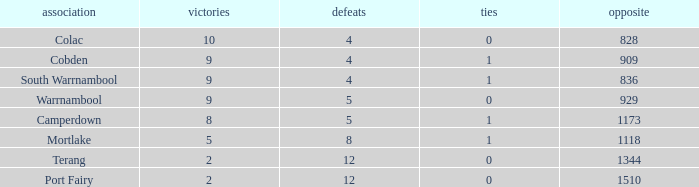What is the sum of wins for Port Fairy with under 1510 against? None. 